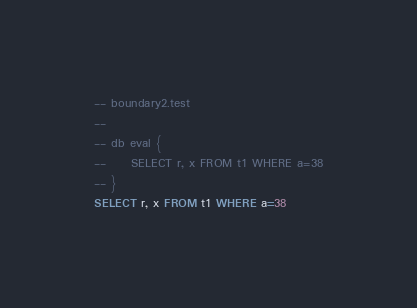Convert code to text. <code><loc_0><loc_0><loc_500><loc_500><_SQL_>-- boundary2.test
-- 
-- db eval {
--     SELECT r, x FROM t1 WHERE a=38
-- }
SELECT r, x FROM t1 WHERE a=38</code> 